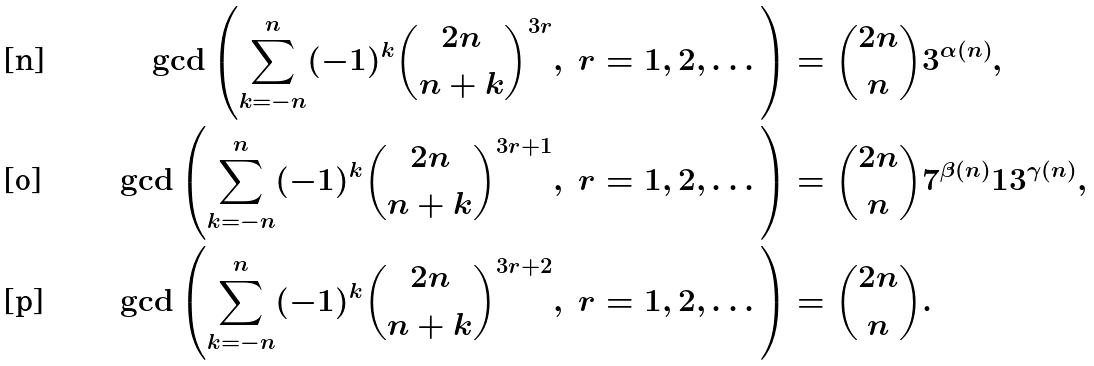Convert formula to latex. <formula><loc_0><loc_0><loc_500><loc_500>\gcd \left ( \sum _ { k = - n } ^ { n } ( - 1 ) ^ { k } { 2 n \choose n + k } ^ { 3 r } , \ r = 1 , 2 , \dots \right ) & = { 2 n \choose n } 3 ^ { \alpha ( n ) } , \\ \gcd \left ( \sum _ { k = - n } ^ { n } ( - 1 ) ^ { k } { 2 n \choose n + k } ^ { 3 r + 1 } , \ r = 1 , 2 , \dots \right ) & = { 2 n \choose n } 7 ^ { \beta ( n ) } 1 3 ^ { \gamma ( n ) } , \\ \gcd \left ( \sum _ { k = - n } ^ { n } ( - 1 ) ^ { k } { 2 n \choose n + k } ^ { 3 r + 2 } , \ r = 1 , 2 , \dots \right ) & = { 2 n \choose n } .</formula> 